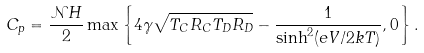<formula> <loc_0><loc_0><loc_500><loc_500>C _ { p } = \frac { { \mathcal { N } } H } { 2 } \max \left \{ 4 \gamma \sqrt { T _ { C } R _ { C } T _ { D } R _ { D } } - \frac { 1 } { \sinh ^ { 2 } ( e V / 2 k T ) } , 0 \right \} .</formula> 